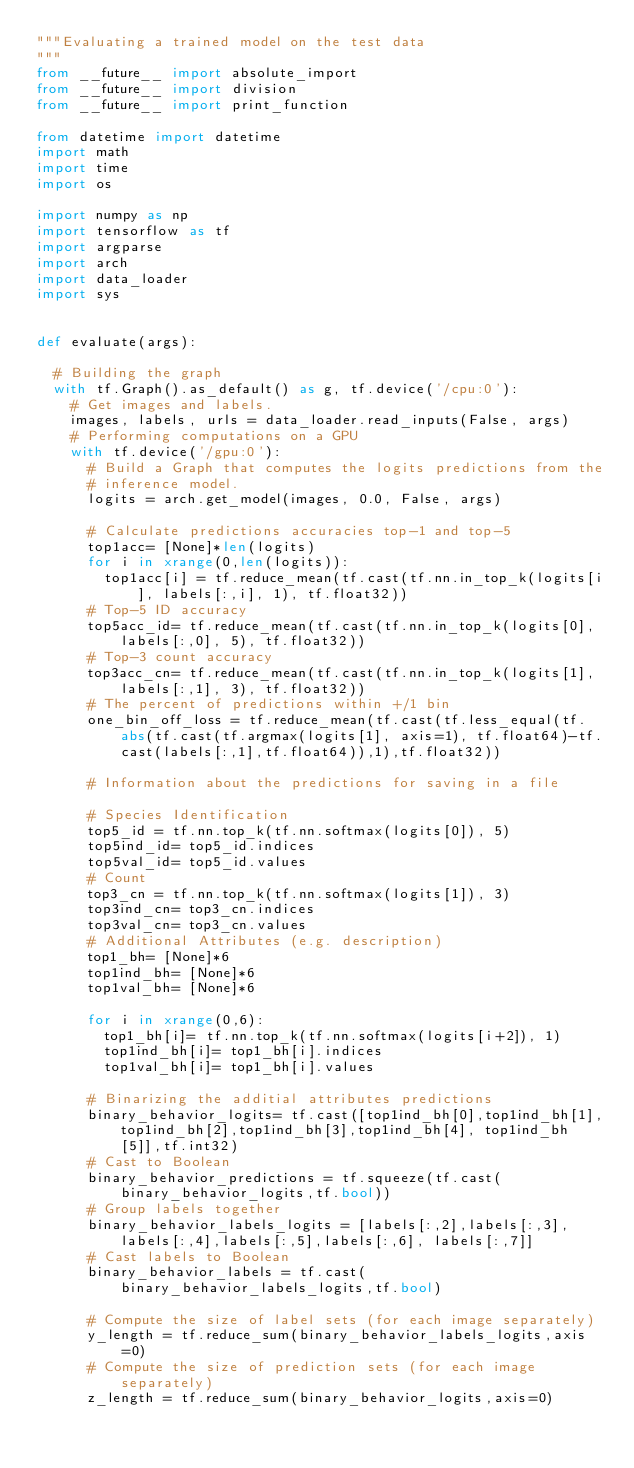<code> <loc_0><loc_0><loc_500><loc_500><_Python_>"""Evaluating a trained model on the test data
"""
from __future__ import absolute_import
from __future__ import division
from __future__ import print_function

from datetime import datetime
import math
import time
import os

import numpy as np
import tensorflow as tf
import argparse
import arch
import data_loader
import sys


def evaluate(args):

  # Building the graph
  with tf.Graph().as_default() as g, tf.device('/cpu:0'):
    # Get images and labels.
    images, labels, urls = data_loader.read_inputs(False, args)
    # Performing computations on a GPU
    with tf.device('/gpu:0'):
      # Build a Graph that computes the logits predictions from the
      # inference model.
      logits = arch.get_model(images, 0.0, False, args)

      # Calculate predictions accuracies top-1 and top-5
      top1acc= [None]*len(logits)
      for i in xrange(0,len(logits)):
        top1acc[i] = tf.reduce_mean(tf.cast(tf.nn.in_top_k(logits[i], labels[:,i], 1), tf.float32))
      # Top-5 ID accuracy
      top5acc_id= tf.reduce_mean(tf.cast(tf.nn.in_top_k(logits[0], labels[:,0], 5), tf.float32))
      # Top-3 count accuracy
      top3acc_cn= tf.reduce_mean(tf.cast(tf.nn.in_top_k(logits[1], labels[:,1], 3), tf.float32)) 
      # The percent of predictions within +/1 bin 
      one_bin_off_loss = tf.reduce_mean(tf.cast(tf.less_equal(tf.abs(tf.cast(tf.argmax(logits[1], axis=1), tf.float64)-tf.cast(labels[:,1],tf.float64)),1),tf.float32))
        
      # Information about the predictions for saving in a file
        
      # Species Identification
      top5_id = tf.nn.top_k(tf.nn.softmax(logits[0]), 5)
      top5ind_id= top5_id.indices
      top5val_id= top5_id.values
      # Count
      top3_cn = tf.nn.top_k(tf.nn.softmax(logits[1]), 3)
      top3ind_cn= top3_cn.indices
      top3val_cn= top3_cn.values
      # Additional Attributes (e.g. description)
      top1_bh= [None]*6
      top1ind_bh= [None]*6
      top1val_bh= [None]*6

      for i in xrange(0,6):
        top1_bh[i]= tf.nn.top_k(tf.nn.softmax(logits[i+2]), 1)
        top1ind_bh[i]= top1_bh[i].indices
        top1val_bh[i]= top1_bh[i].values

      # Binarizing the additial attributes predictions
      binary_behavior_logits= tf.cast([top1ind_bh[0],top1ind_bh[1],top1ind_bh[2],top1ind_bh[3],top1ind_bh[4], top1ind_bh[5]],tf.int32)
      # Cast to Boolean
      binary_behavior_predictions = tf.squeeze(tf.cast(binary_behavior_logits,tf.bool))
      # Group labels together
      binary_behavior_labels_logits = [labels[:,2],labels[:,3],labels[:,4],labels[:,5],labels[:,6], labels[:,7]]
      # Cast labels to Boolean
      binary_behavior_labels = tf.cast(binary_behavior_labels_logits,tf.bool)

      # Compute the size of label sets (for each image separately)
      y_length = tf.reduce_sum(binary_behavior_labels_logits,axis=0) 
      # Compute the size of prediction sets (for each image separately)
      z_length = tf.reduce_sum(binary_behavior_logits,axis=0)</code> 